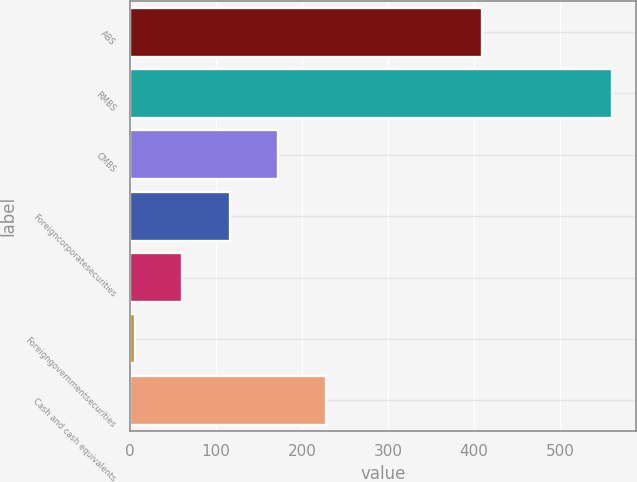Convert chart to OTSL. <chart><loc_0><loc_0><loc_500><loc_500><bar_chart><fcel>ABS<fcel>RMBS<fcel>CMBS<fcel>Foreigncorporatesecurities<fcel>Unnamed: 4<fcel>Foreigngovernmentsecurities<fcel>Cash and cash equivalents<nl><fcel>409<fcel>561<fcel>171.8<fcel>116.2<fcel>60.6<fcel>5<fcel>227.4<nl></chart> 